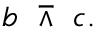Convert formula to latex. <formula><loc_0><loc_0><loc_500><loc_500>b \ \bar { w } e d g e \ c .</formula> 